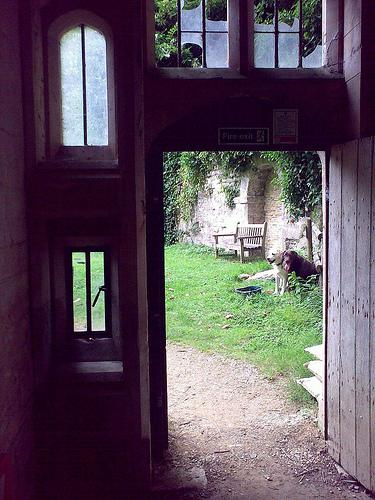Question: where is the broken window?
Choices:
A. Beside the door.
B. To the right of the door.
C. Above door.
D. To the left of the door.
Answer with the letter. Answer: C Question: what is the animal?
Choices:
A. Cat.
B. A dog.
C. Mouse.
D. Goat.
Answer with the letter. Answer: B Question: why is the child running?
Choices:
A. No child.
B. He is happy.
C. He is afraid.
D. He is playing.
Answer with the letter. Answer: A 